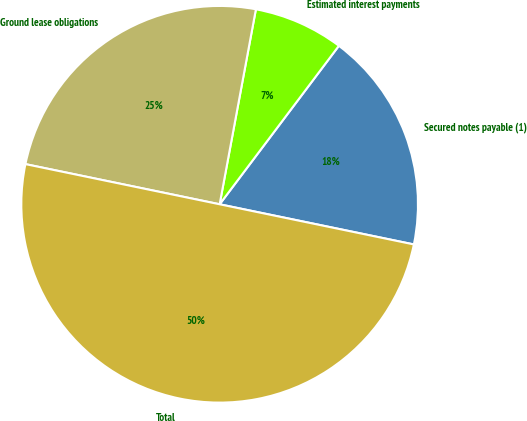<chart> <loc_0><loc_0><loc_500><loc_500><pie_chart><fcel>Secured notes payable (1)<fcel>Estimated interest payments<fcel>Ground lease obligations<fcel>Total<nl><fcel>17.98%<fcel>7.34%<fcel>24.68%<fcel>50.0%<nl></chart> 